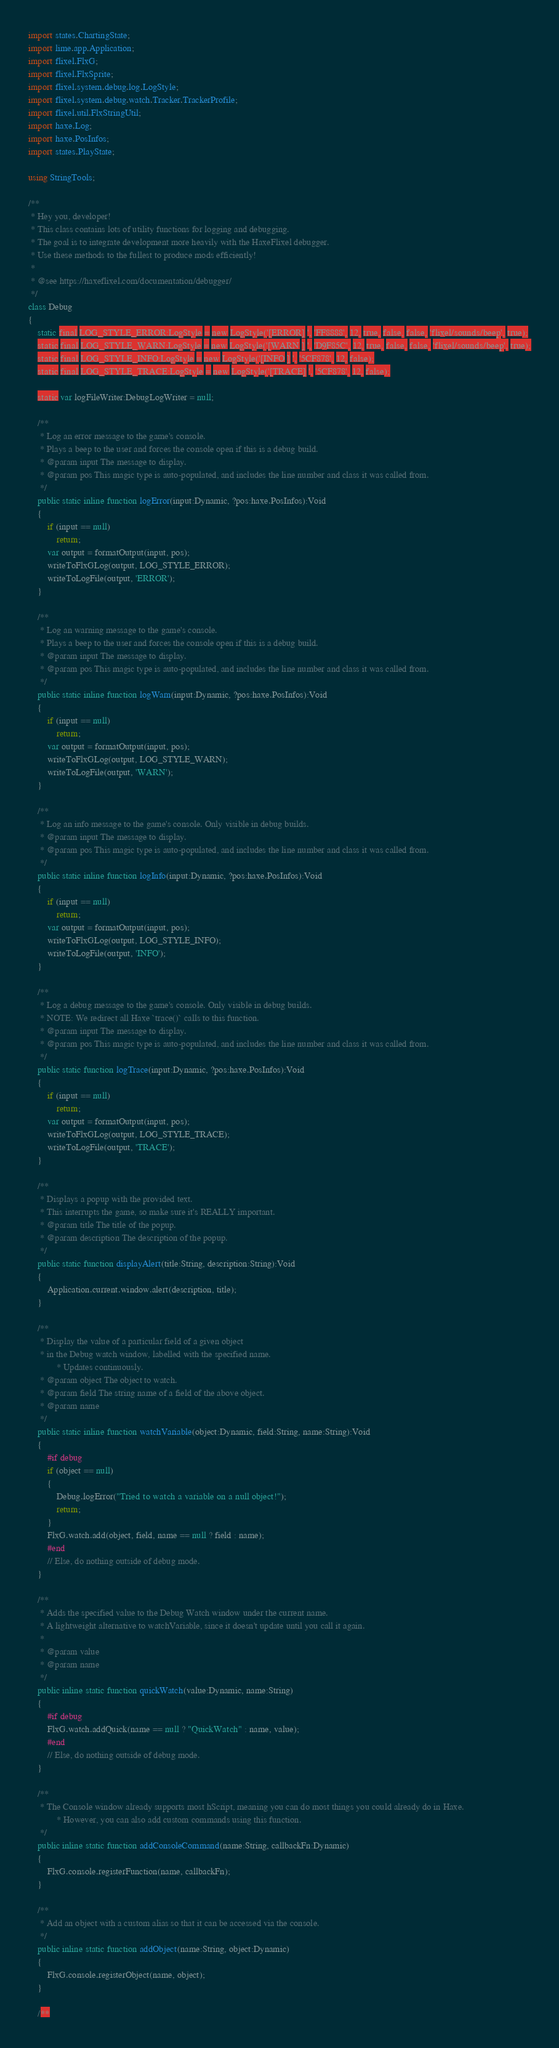<code> <loc_0><loc_0><loc_500><loc_500><_Haxe_>import states.ChartingState;
import lime.app.Application;
import flixel.FlxG;
import flixel.FlxSprite;
import flixel.system.debug.log.LogStyle;
import flixel.system.debug.watch.Tracker.TrackerProfile;
import flixel.util.FlxStringUtil;
import haxe.Log;
import haxe.PosInfos;
import states.PlayState;

using StringTools;

/**
 * Hey you, developer!
 * This class contains lots of utility functions for logging and debugging.
 * The goal is to integrate development more heavily with the HaxeFlixel debugger.
 * Use these methods to the fullest to produce mods efficiently!
 * 
 * @see https://haxeflixel.com/documentation/debugger/
 */
class Debug
{
	static final LOG_STYLE_ERROR:LogStyle = new LogStyle('[ERROR] ', 'FF8888', 12, true, false, false, 'flixel/sounds/beep', true);
	static final LOG_STYLE_WARN:LogStyle = new LogStyle('[WARN ] ', 'D9F85C', 12, true, false, false, 'flixel/sounds/beep', true);
	static final LOG_STYLE_INFO:LogStyle = new LogStyle('[INFO ] ', '5CF878', 12, false);
	static final LOG_STYLE_TRACE:LogStyle = new LogStyle('[TRACE] ', '5CF878', 12, false);

	static var logFileWriter:DebugLogWriter = null;

	/**
	 * Log an error message to the game's console.
	 * Plays a beep to the user and forces the console open if this is a debug build.
	 * @param input The message to display.
	 * @param pos This magic type is auto-populated, and includes the line number and class it was called from.
	 */
	public static inline function logError(input:Dynamic, ?pos:haxe.PosInfos):Void
	{
		if (input == null)
			return;
		var output = formatOutput(input, pos);
		writeToFlxGLog(output, LOG_STYLE_ERROR);
		writeToLogFile(output, 'ERROR');
	}

	/**
	 * Log an warning message to the game's console.
	 * Plays a beep to the user and forces the console open if this is a debug build.
	 * @param input The message to display.
	 * @param pos This magic type is auto-populated, and includes the line number and class it was called from.
	 */
	public static inline function logWarn(input:Dynamic, ?pos:haxe.PosInfos):Void
	{
		if (input == null)
			return;
		var output = formatOutput(input, pos);
		writeToFlxGLog(output, LOG_STYLE_WARN);
		writeToLogFile(output, 'WARN');
	}

	/**
	 * Log an info message to the game's console. Only visible in debug builds.
	 * @param input The message to display.
	 * @param pos This magic type is auto-populated, and includes the line number and class it was called from.
	 */
	public static inline function logInfo(input:Dynamic, ?pos:haxe.PosInfos):Void
	{
		if (input == null)
			return;
		var output = formatOutput(input, pos);
		writeToFlxGLog(output, LOG_STYLE_INFO);
		writeToLogFile(output, 'INFO');
	}

	/**
	 * Log a debug message to the game's console. Only visible in debug builds.
	 * NOTE: We redirect all Haxe `trace()` calls to this function.
	 * @param input The message to display.
	 * @param pos This magic type is auto-populated, and includes the line number and class it was called from.
	 */
	public static function logTrace(input:Dynamic, ?pos:haxe.PosInfos):Void
	{
		if (input == null)
			return;
		var output = formatOutput(input, pos);
		writeToFlxGLog(output, LOG_STYLE_TRACE);
		writeToLogFile(output, 'TRACE');
	}

	/**
	 * Displays a popup with the provided text.
	 * This interrupts the game, so make sure it's REALLY important.
	 * @param title The title of the popup.
	 * @param description The description of the popup.
	 */
	public static function displayAlert(title:String, description:String):Void
	{
		Application.current.window.alert(description, title);
	}

	/**
	 * Display the value of a particular field of a given object
	 * in the Debug watch window, labelled with the specified name.
	 		* Updates continuously.
	 * @param object The object to watch.
	 * @param field The string name of a field of the above object.
	 * @param name
	 */
	public static inline function watchVariable(object:Dynamic, field:String, name:String):Void
	{
		#if debug
		if (object == null)
		{
			Debug.logError("Tried to watch a variable on a null object!");
			return;
		}
		FlxG.watch.add(object, field, name == null ? field : name);
		#end
		// Else, do nothing outside of debug mode.
	}

	/**
	 * Adds the specified value to the Debug Watch window under the current name.
	 * A lightweight alternative to watchVariable, since it doesn't update until you call it again.
	 * 
	 * @param value 
	 * @param name 
	 */
	public inline static function quickWatch(value:Dynamic, name:String)
	{
		#if debug
		FlxG.watch.addQuick(name == null ? "QuickWatch" : name, value);
		#end
		// Else, do nothing outside of debug mode.
	}

	/**
	 * The Console window already supports most hScript, meaning you can do most things you could already do in Haxe.
	 		* However, you can also add custom commands using this function.
	 */
	public inline static function addConsoleCommand(name:String, callbackFn:Dynamic)
	{
		FlxG.console.registerFunction(name, callbackFn);
	}

	/**
	 * Add an object with a custom alias so that it can be accessed via the console.
	 */
	public inline static function addObject(name:String, object:Dynamic)
	{
		FlxG.console.registerObject(name, object);
	}

	/**</code> 